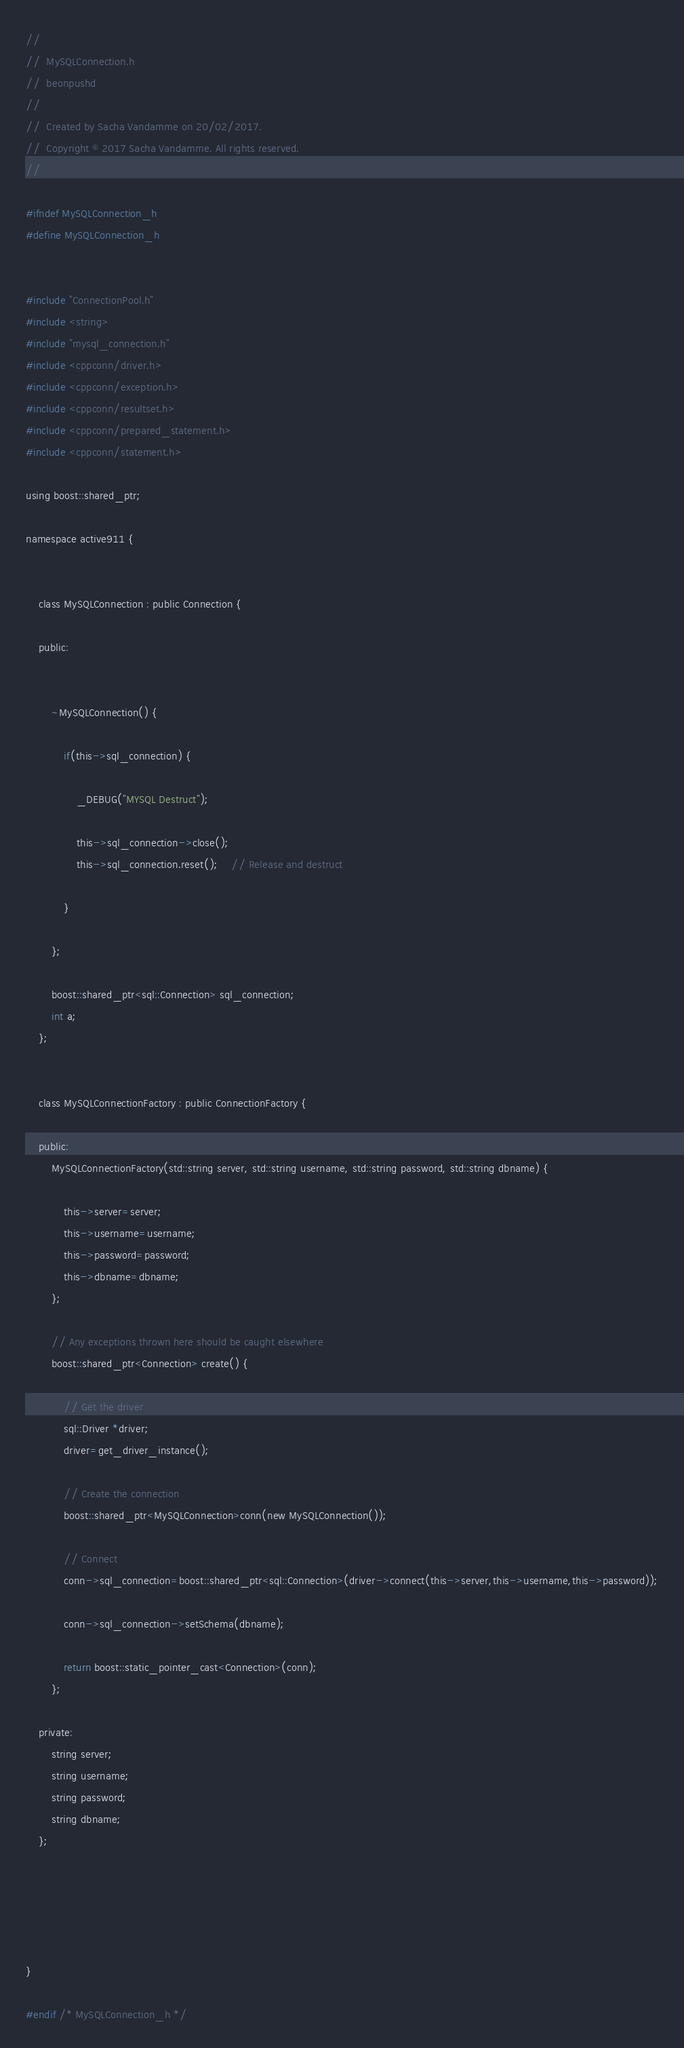<code> <loc_0><loc_0><loc_500><loc_500><_C_>//
//  MySQLConnection.h
//  beonpushd
//
//  Created by Sacha Vandamme on 20/02/2017.
//  Copyright © 2017 Sacha Vandamme. All rights reserved.
//

#ifndef MySQLConnection_h
#define MySQLConnection_h


#include "ConnectionPool.h"
#include <string>
#include "mysql_connection.h"
#include <cppconn/driver.h>
#include <cppconn/exception.h>
#include <cppconn/resultset.h>
#include <cppconn/prepared_statement.h>
#include <cppconn/statement.h>

using boost::shared_ptr;

namespace active911 {
    
    
    class MySQLConnection : public Connection {
        
    public:
        
        
        ~MySQLConnection() {
            
            if(this->sql_connection) {
                
                _DEBUG("MYSQL Destruct");
                
                this->sql_connection->close();
                this->sql_connection.reset(); 	// Release and destruct
                
            }
            
        };
        
        boost::shared_ptr<sql::Connection> sql_connection;
        int a;
    };
    
    
    class MySQLConnectionFactory : public ConnectionFactory {
        
    public:
        MySQLConnectionFactory(std::string server, std::string username, std::string password, std::string dbname) {
            
            this->server=server;
            this->username=username;
            this->password=password;
            this->dbname=dbname;
        };
        
        // Any exceptions thrown here should be caught elsewhere
        boost::shared_ptr<Connection> create() {
            
            // Get the driver
            sql::Driver *driver;
            driver=get_driver_instance();
            
            // Create the connection
            boost::shared_ptr<MySQLConnection>conn(new MySQLConnection());
            
            // Connect
            conn->sql_connection=boost::shared_ptr<sql::Connection>(driver->connect(this->server,this->username,this->password));
            
            conn->sql_connection->setSchema(dbname);
            
            return boost::static_pointer_cast<Connection>(conn);
        };
        
    private:
        string server;
        string username;
        string password;
        string dbname;
    };
    
    
    
    
    
}

#endif /* MySQLConnection_h */
</code> 